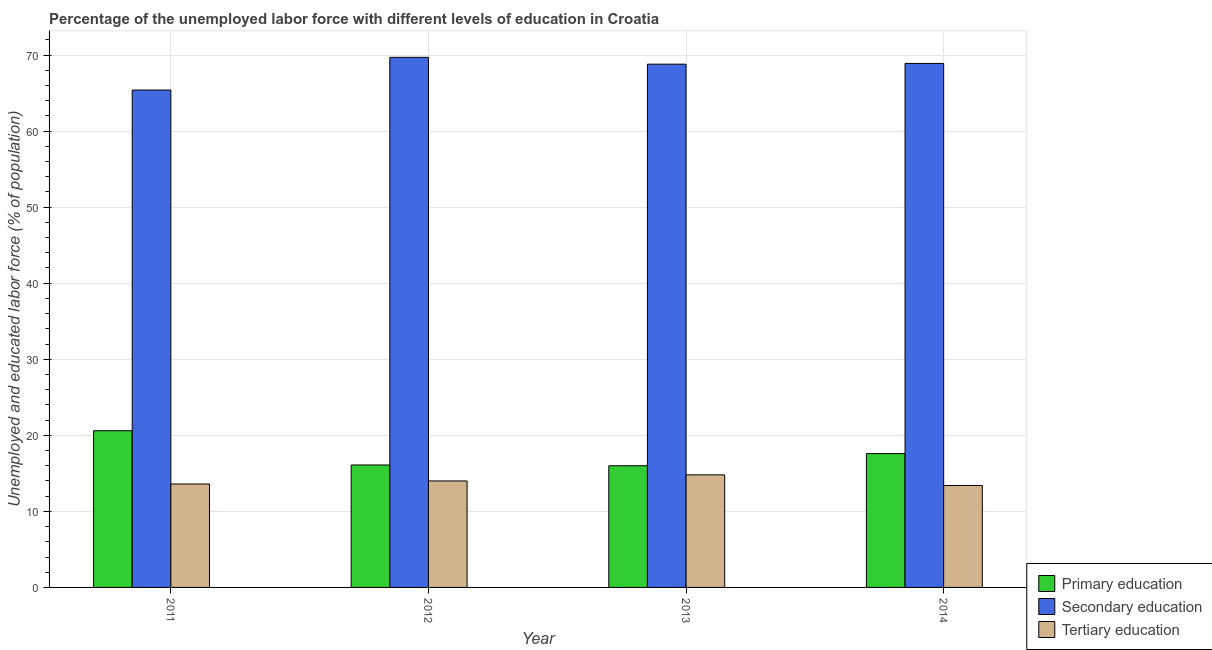Are the number of bars per tick equal to the number of legend labels?
Make the answer very short. Yes. Are the number of bars on each tick of the X-axis equal?
Your answer should be compact. Yes. How many bars are there on the 1st tick from the left?
Keep it short and to the point. 3. What is the percentage of labor force who received secondary education in 2013?
Ensure brevity in your answer.  68.8. Across all years, what is the maximum percentage of labor force who received primary education?
Keep it short and to the point. 20.6. Across all years, what is the minimum percentage of labor force who received tertiary education?
Provide a short and direct response. 13.4. In which year was the percentage of labor force who received tertiary education maximum?
Give a very brief answer. 2013. In which year was the percentage of labor force who received tertiary education minimum?
Your answer should be very brief. 2014. What is the total percentage of labor force who received tertiary education in the graph?
Make the answer very short. 55.8. What is the difference between the percentage of labor force who received tertiary education in 2012 and that in 2013?
Your answer should be compact. -0.8. What is the difference between the percentage of labor force who received primary education in 2013 and the percentage of labor force who received tertiary education in 2012?
Provide a short and direct response. -0.1. What is the average percentage of labor force who received tertiary education per year?
Offer a terse response. 13.95. In how many years, is the percentage of labor force who received primary education greater than 36 %?
Your answer should be compact. 0. What is the ratio of the percentage of labor force who received secondary education in 2012 to that in 2014?
Keep it short and to the point. 1.01. Is the difference between the percentage of labor force who received primary education in 2013 and 2014 greater than the difference between the percentage of labor force who received secondary education in 2013 and 2014?
Make the answer very short. No. What is the difference between the highest and the second highest percentage of labor force who received secondary education?
Ensure brevity in your answer.  0.8. What is the difference between the highest and the lowest percentage of labor force who received secondary education?
Provide a succinct answer. 4.3. In how many years, is the percentage of labor force who received primary education greater than the average percentage of labor force who received primary education taken over all years?
Give a very brief answer. 2. What does the 2nd bar from the left in 2012 represents?
Your answer should be compact. Secondary education. What does the 2nd bar from the right in 2012 represents?
Make the answer very short. Secondary education. Are all the bars in the graph horizontal?
Keep it short and to the point. No. How many years are there in the graph?
Make the answer very short. 4. Does the graph contain grids?
Your response must be concise. Yes. How are the legend labels stacked?
Your response must be concise. Vertical. What is the title of the graph?
Give a very brief answer. Percentage of the unemployed labor force with different levels of education in Croatia. Does "Spain" appear as one of the legend labels in the graph?
Provide a succinct answer. No. What is the label or title of the X-axis?
Keep it short and to the point. Year. What is the label or title of the Y-axis?
Ensure brevity in your answer.  Unemployed and educated labor force (% of population). What is the Unemployed and educated labor force (% of population) in Primary education in 2011?
Ensure brevity in your answer.  20.6. What is the Unemployed and educated labor force (% of population) of Secondary education in 2011?
Your answer should be very brief. 65.4. What is the Unemployed and educated labor force (% of population) of Tertiary education in 2011?
Provide a succinct answer. 13.6. What is the Unemployed and educated labor force (% of population) in Primary education in 2012?
Provide a succinct answer. 16.1. What is the Unemployed and educated labor force (% of population) in Secondary education in 2012?
Provide a short and direct response. 69.7. What is the Unemployed and educated labor force (% of population) in Tertiary education in 2012?
Make the answer very short. 14. What is the Unemployed and educated labor force (% of population) in Primary education in 2013?
Offer a terse response. 16. What is the Unemployed and educated labor force (% of population) of Secondary education in 2013?
Keep it short and to the point. 68.8. What is the Unemployed and educated labor force (% of population) in Tertiary education in 2013?
Provide a short and direct response. 14.8. What is the Unemployed and educated labor force (% of population) of Primary education in 2014?
Offer a terse response. 17.6. What is the Unemployed and educated labor force (% of population) in Secondary education in 2014?
Provide a short and direct response. 68.9. What is the Unemployed and educated labor force (% of population) in Tertiary education in 2014?
Offer a very short reply. 13.4. Across all years, what is the maximum Unemployed and educated labor force (% of population) of Primary education?
Give a very brief answer. 20.6. Across all years, what is the maximum Unemployed and educated labor force (% of population) in Secondary education?
Give a very brief answer. 69.7. Across all years, what is the maximum Unemployed and educated labor force (% of population) of Tertiary education?
Offer a terse response. 14.8. Across all years, what is the minimum Unemployed and educated labor force (% of population) of Secondary education?
Ensure brevity in your answer.  65.4. Across all years, what is the minimum Unemployed and educated labor force (% of population) of Tertiary education?
Ensure brevity in your answer.  13.4. What is the total Unemployed and educated labor force (% of population) in Primary education in the graph?
Make the answer very short. 70.3. What is the total Unemployed and educated labor force (% of population) in Secondary education in the graph?
Your response must be concise. 272.8. What is the total Unemployed and educated labor force (% of population) in Tertiary education in the graph?
Make the answer very short. 55.8. What is the difference between the Unemployed and educated labor force (% of population) of Primary education in 2011 and that in 2012?
Make the answer very short. 4.5. What is the difference between the Unemployed and educated labor force (% of population) in Secondary education in 2011 and that in 2012?
Your answer should be very brief. -4.3. What is the difference between the Unemployed and educated labor force (% of population) in Tertiary education in 2011 and that in 2013?
Your answer should be compact. -1.2. What is the difference between the Unemployed and educated labor force (% of population) of Primary education in 2011 and that in 2014?
Your answer should be very brief. 3. What is the difference between the Unemployed and educated labor force (% of population) of Secondary education in 2012 and that in 2013?
Provide a short and direct response. 0.9. What is the difference between the Unemployed and educated labor force (% of population) of Tertiary education in 2012 and that in 2013?
Offer a very short reply. -0.8. What is the difference between the Unemployed and educated labor force (% of population) in Primary education in 2012 and that in 2014?
Ensure brevity in your answer.  -1.5. What is the difference between the Unemployed and educated labor force (% of population) in Secondary education in 2012 and that in 2014?
Ensure brevity in your answer.  0.8. What is the difference between the Unemployed and educated labor force (% of population) in Primary education in 2013 and that in 2014?
Provide a succinct answer. -1.6. What is the difference between the Unemployed and educated labor force (% of population) of Secondary education in 2013 and that in 2014?
Make the answer very short. -0.1. What is the difference between the Unemployed and educated labor force (% of population) in Tertiary education in 2013 and that in 2014?
Give a very brief answer. 1.4. What is the difference between the Unemployed and educated labor force (% of population) in Primary education in 2011 and the Unemployed and educated labor force (% of population) in Secondary education in 2012?
Make the answer very short. -49.1. What is the difference between the Unemployed and educated labor force (% of population) of Secondary education in 2011 and the Unemployed and educated labor force (% of population) of Tertiary education in 2012?
Give a very brief answer. 51.4. What is the difference between the Unemployed and educated labor force (% of population) of Primary education in 2011 and the Unemployed and educated labor force (% of population) of Secondary education in 2013?
Make the answer very short. -48.2. What is the difference between the Unemployed and educated labor force (% of population) in Secondary education in 2011 and the Unemployed and educated labor force (% of population) in Tertiary education in 2013?
Offer a very short reply. 50.6. What is the difference between the Unemployed and educated labor force (% of population) in Primary education in 2011 and the Unemployed and educated labor force (% of population) in Secondary education in 2014?
Offer a terse response. -48.3. What is the difference between the Unemployed and educated labor force (% of population) of Primary education in 2011 and the Unemployed and educated labor force (% of population) of Tertiary education in 2014?
Ensure brevity in your answer.  7.2. What is the difference between the Unemployed and educated labor force (% of population) of Secondary education in 2011 and the Unemployed and educated labor force (% of population) of Tertiary education in 2014?
Offer a terse response. 52. What is the difference between the Unemployed and educated labor force (% of population) in Primary education in 2012 and the Unemployed and educated labor force (% of population) in Secondary education in 2013?
Your answer should be very brief. -52.7. What is the difference between the Unemployed and educated labor force (% of population) of Primary education in 2012 and the Unemployed and educated labor force (% of population) of Tertiary education in 2013?
Ensure brevity in your answer.  1.3. What is the difference between the Unemployed and educated labor force (% of population) of Secondary education in 2012 and the Unemployed and educated labor force (% of population) of Tertiary education in 2013?
Give a very brief answer. 54.9. What is the difference between the Unemployed and educated labor force (% of population) in Primary education in 2012 and the Unemployed and educated labor force (% of population) in Secondary education in 2014?
Offer a terse response. -52.8. What is the difference between the Unemployed and educated labor force (% of population) of Secondary education in 2012 and the Unemployed and educated labor force (% of population) of Tertiary education in 2014?
Offer a terse response. 56.3. What is the difference between the Unemployed and educated labor force (% of population) of Primary education in 2013 and the Unemployed and educated labor force (% of population) of Secondary education in 2014?
Offer a terse response. -52.9. What is the difference between the Unemployed and educated labor force (% of population) of Primary education in 2013 and the Unemployed and educated labor force (% of population) of Tertiary education in 2014?
Offer a terse response. 2.6. What is the difference between the Unemployed and educated labor force (% of population) of Secondary education in 2013 and the Unemployed and educated labor force (% of population) of Tertiary education in 2014?
Give a very brief answer. 55.4. What is the average Unemployed and educated labor force (% of population) in Primary education per year?
Provide a succinct answer. 17.57. What is the average Unemployed and educated labor force (% of population) of Secondary education per year?
Your response must be concise. 68.2. What is the average Unemployed and educated labor force (% of population) of Tertiary education per year?
Provide a succinct answer. 13.95. In the year 2011, what is the difference between the Unemployed and educated labor force (% of population) of Primary education and Unemployed and educated labor force (% of population) of Secondary education?
Offer a very short reply. -44.8. In the year 2011, what is the difference between the Unemployed and educated labor force (% of population) of Secondary education and Unemployed and educated labor force (% of population) of Tertiary education?
Your response must be concise. 51.8. In the year 2012, what is the difference between the Unemployed and educated labor force (% of population) of Primary education and Unemployed and educated labor force (% of population) of Secondary education?
Your answer should be very brief. -53.6. In the year 2012, what is the difference between the Unemployed and educated labor force (% of population) in Primary education and Unemployed and educated labor force (% of population) in Tertiary education?
Provide a succinct answer. 2.1. In the year 2012, what is the difference between the Unemployed and educated labor force (% of population) in Secondary education and Unemployed and educated labor force (% of population) in Tertiary education?
Your answer should be very brief. 55.7. In the year 2013, what is the difference between the Unemployed and educated labor force (% of population) in Primary education and Unemployed and educated labor force (% of population) in Secondary education?
Your answer should be very brief. -52.8. In the year 2014, what is the difference between the Unemployed and educated labor force (% of population) of Primary education and Unemployed and educated labor force (% of population) of Secondary education?
Your answer should be very brief. -51.3. In the year 2014, what is the difference between the Unemployed and educated labor force (% of population) of Primary education and Unemployed and educated labor force (% of population) of Tertiary education?
Offer a very short reply. 4.2. In the year 2014, what is the difference between the Unemployed and educated labor force (% of population) of Secondary education and Unemployed and educated labor force (% of population) of Tertiary education?
Your answer should be compact. 55.5. What is the ratio of the Unemployed and educated labor force (% of population) of Primary education in 2011 to that in 2012?
Make the answer very short. 1.28. What is the ratio of the Unemployed and educated labor force (% of population) of Secondary education in 2011 to that in 2012?
Give a very brief answer. 0.94. What is the ratio of the Unemployed and educated labor force (% of population) in Tertiary education in 2011 to that in 2012?
Your answer should be very brief. 0.97. What is the ratio of the Unemployed and educated labor force (% of population) of Primary education in 2011 to that in 2013?
Offer a terse response. 1.29. What is the ratio of the Unemployed and educated labor force (% of population) in Secondary education in 2011 to that in 2013?
Ensure brevity in your answer.  0.95. What is the ratio of the Unemployed and educated labor force (% of population) of Tertiary education in 2011 to that in 2013?
Ensure brevity in your answer.  0.92. What is the ratio of the Unemployed and educated labor force (% of population) of Primary education in 2011 to that in 2014?
Keep it short and to the point. 1.17. What is the ratio of the Unemployed and educated labor force (% of population) of Secondary education in 2011 to that in 2014?
Give a very brief answer. 0.95. What is the ratio of the Unemployed and educated labor force (% of population) in Tertiary education in 2011 to that in 2014?
Give a very brief answer. 1.01. What is the ratio of the Unemployed and educated labor force (% of population) in Secondary education in 2012 to that in 2013?
Give a very brief answer. 1.01. What is the ratio of the Unemployed and educated labor force (% of population) of Tertiary education in 2012 to that in 2013?
Keep it short and to the point. 0.95. What is the ratio of the Unemployed and educated labor force (% of population) in Primary education in 2012 to that in 2014?
Offer a terse response. 0.91. What is the ratio of the Unemployed and educated labor force (% of population) of Secondary education in 2012 to that in 2014?
Your response must be concise. 1.01. What is the ratio of the Unemployed and educated labor force (% of population) in Tertiary education in 2012 to that in 2014?
Your answer should be compact. 1.04. What is the ratio of the Unemployed and educated labor force (% of population) of Secondary education in 2013 to that in 2014?
Offer a very short reply. 1. What is the ratio of the Unemployed and educated labor force (% of population) of Tertiary education in 2013 to that in 2014?
Offer a very short reply. 1.1. What is the difference between the highest and the second highest Unemployed and educated labor force (% of population) in Primary education?
Your answer should be very brief. 3. What is the difference between the highest and the second highest Unemployed and educated labor force (% of population) in Secondary education?
Provide a succinct answer. 0.8. What is the difference between the highest and the second highest Unemployed and educated labor force (% of population) of Tertiary education?
Your response must be concise. 0.8. What is the difference between the highest and the lowest Unemployed and educated labor force (% of population) of Primary education?
Provide a short and direct response. 4.6. What is the difference between the highest and the lowest Unemployed and educated labor force (% of population) in Secondary education?
Offer a terse response. 4.3. What is the difference between the highest and the lowest Unemployed and educated labor force (% of population) of Tertiary education?
Provide a succinct answer. 1.4. 